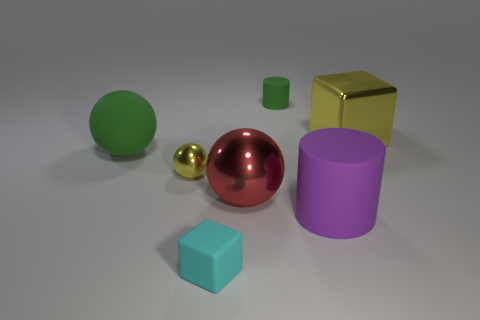There is another tiny metal thing that is the same shape as the red object; what color is it?
Provide a short and direct response. Yellow. How many big metallic cubes have the same color as the big cylinder?
Your response must be concise. 0. Is the number of tiny green rubber things that are in front of the rubber sphere greater than the number of big brown shiny blocks?
Offer a very short reply. No. There is a big matte thing that is on the right side of the green matte thing right of the small cyan block; what is its color?
Ensure brevity in your answer.  Purple. What number of objects are either rubber things in front of the small green thing or green matte objects on the left side of the red thing?
Your answer should be very brief. 3. What color is the large block?
Keep it short and to the point. Yellow. How many other spheres are made of the same material as the red sphere?
Keep it short and to the point. 1. Is the number of purple things greater than the number of tiny brown blocks?
Offer a very short reply. Yes. There is a rubber object that is to the left of the cyan cube; what number of cylinders are in front of it?
Offer a terse response. 1. What number of objects are big matte objects that are right of the big green matte sphere or tiny spheres?
Your answer should be very brief. 2. 